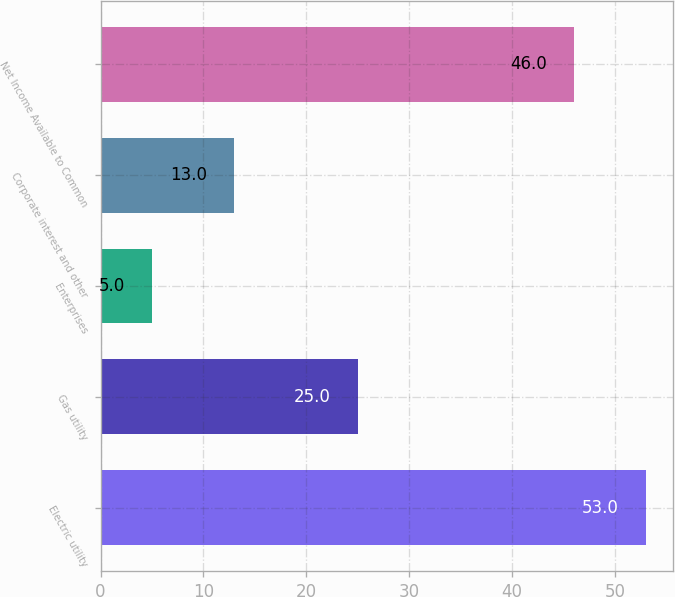Convert chart. <chart><loc_0><loc_0><loc_500><loc_500><bar_chart><fcel>Electric utility<fcel>Gas utility<fcel>Enterprises<fcel>Corporate interest and other<fcel>Net Income Available to Common<nl><fcel>53<fcel>25<fcel>5<fcel>13<fcel>46<nl></chart> 